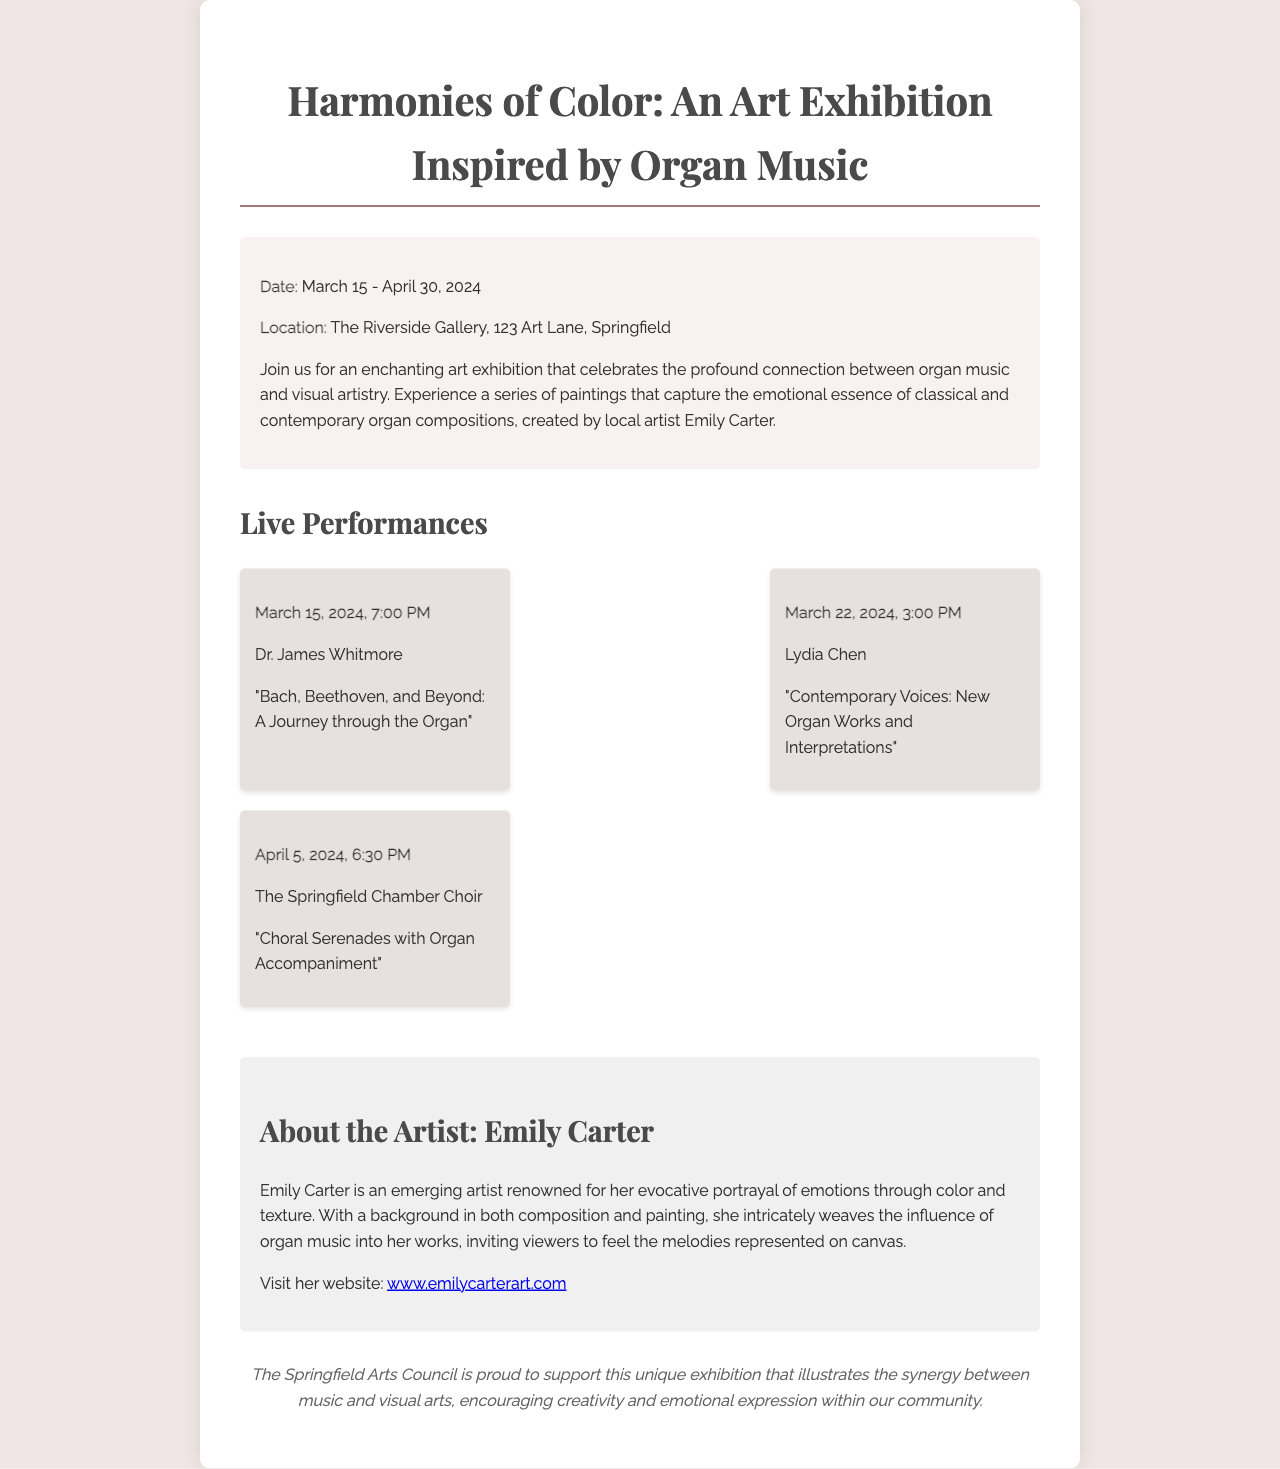What is the title of the art exhibition? The title is found at the beginning of the document, prominently displayed as the main heading.
Answer: Harmonies of Color: An Art Exhibition Inspired by Organ Music What dates will the exhibition be open? The dates can be found in the event information section stating the duration of the exhibition.
Answer: March 15 - April 30, 2024 Where is the exhibition located? The location is specified in the event information, providing the address of the gallery.
Answer: The Riverside Gallery, 123 Art Lane, Springfield Who is performing on March 22, 2024? The performance information lists Dr. James Whitmore, Lydia Chen, and the Springfield Chamber Choir.
Answer: Lydia Chen What is the theme of the exhibition? The theme is described in the event information section, highlighting the connection between music and art.
Answer: The profound connection between organ music and visual artistry Who is the artist featured in this exhibition? The artist is introduced in the section about the artist, including her name and some background information.
Answer: Emily Carter What type of performances will be held during the exhibition? The performances mentioned include specific themes, which can be summarized based on the titles provided within the performance section.
Answer: Live performances Which organization is sponsoring the exhibition? The sponsor information is located at the end of the document, revealing which council supports this exhibition.
Answer: The Springfield Arts Council 